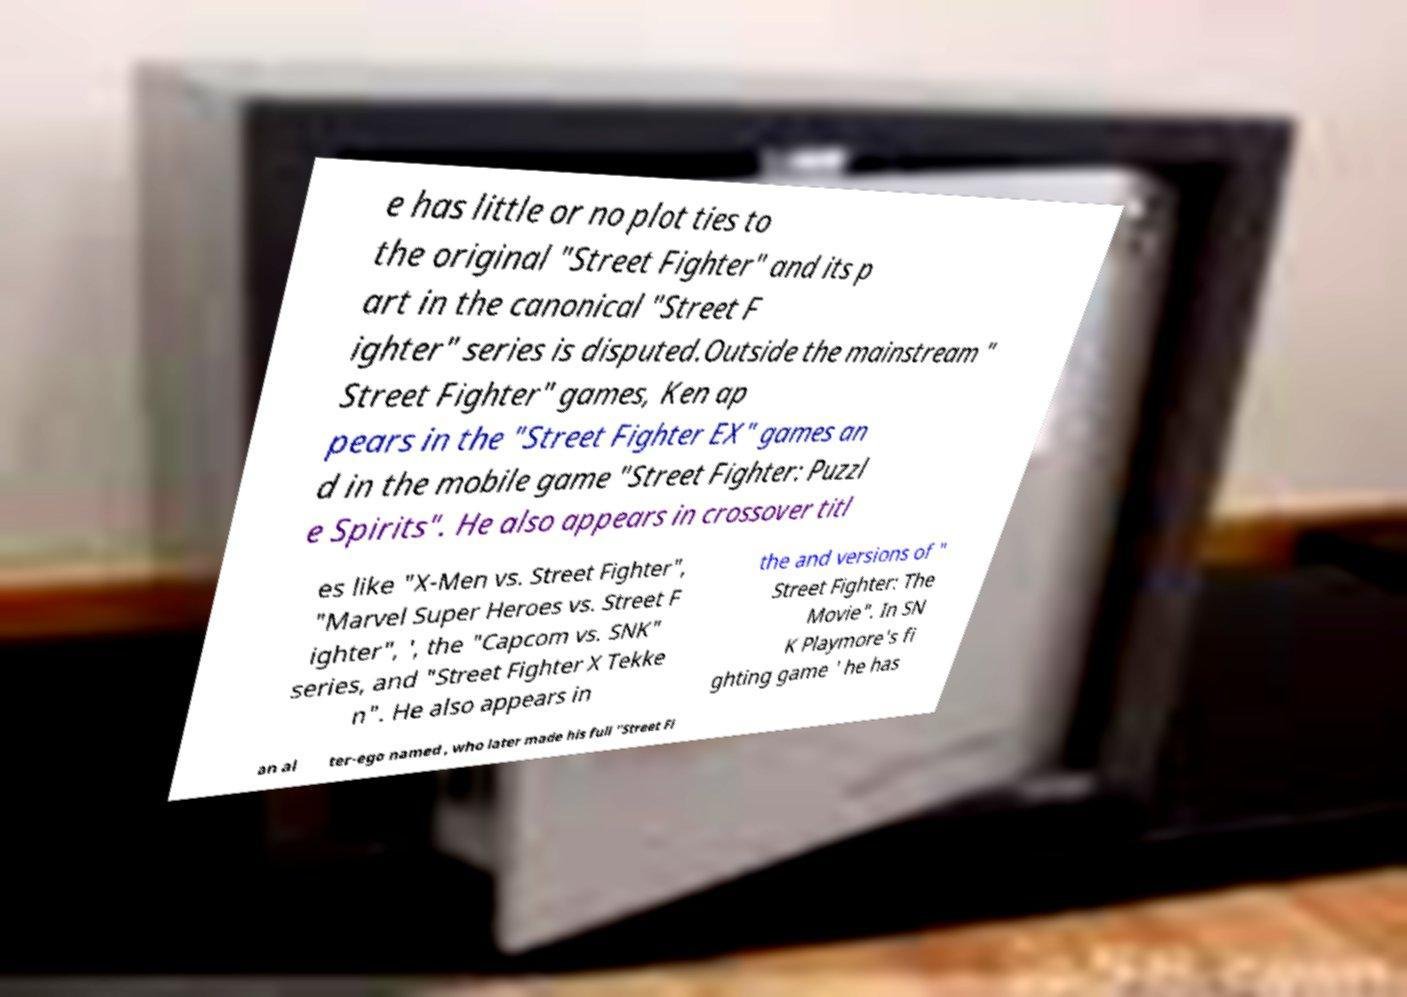Could you assist in decoding the text presented in this image and type it out clearly? e has little or no plot ties to the original "Street Fighter" and its p art in the canonical "Street F ighter" series is disputed.Outside the mainstream " Street Fighter" games, Ken ap pears in the "Street Fighter EX" games an d in the mobile game "Street Fighter: Puzzl e Spirits". He also appears in crossover titl es like "X-Men vs. Street Fighter", "Marvel Super Heroes vs. Street F ighter", ', the "Capcom vs. SNK" series, and "Street Fighter X Tekke n". He also appears in the and versions of " Street Fighter: The Movie". In SN K Playmore's fi ghting game ' he has an al ter-ego named , who later made his full "Street Fi 